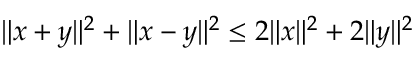Convert formula to latex. <formula><loc_0><loc_0><loc_500><loc_500>\| x + y \| ^ { 2 } + \| x - y \| ^ { 2 } \leq 2 \| x \| ^ { 2 } + 2 \| y \| ^ { 2 }</formula> 